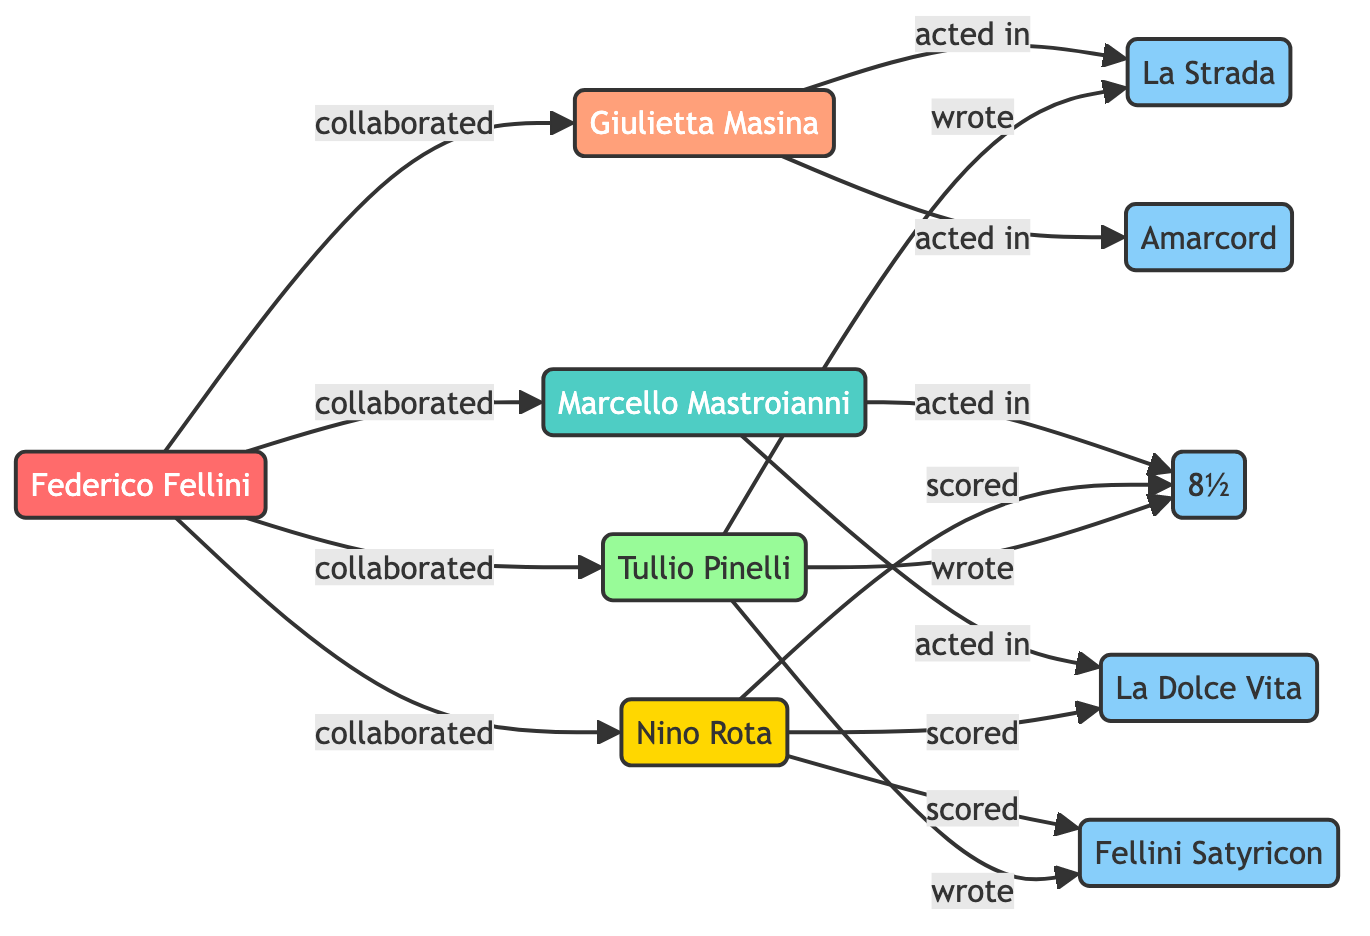What is Federico Fellini's role in the diagram? The diagram clearly shows that Federico Fellini is labeled as a director, which is indicated by the node containing his name and the class associated with directors.
Answer: director How many films are depicted in the diagram? By counting the film nodes in the diagram, there are five specific films listed: Amarcord, La Strada, 8½, La Dolce Vita, and Fellini Satyricon.
Answer: 5 Who acted in Amarcord? The diagram indicates that Giulietta Masina is connected to the Amarcord node, clearly showing she acted in this film.
Answer: Giulietta Masina Which composer worked with Fellini on 8½? The diagram connects Nino Rota as a composer that scored 8½, establishing the relationship through the lines connecting these nodes.
Answer: Nino Rota Which film did Tullio Pinelli write? The diagram illustrates that Tullio Pinelli is linked to La Strada, 8½, and Fellini Satyricon through writing relationships, so he wrote La Strada among others.
Answer: La Strada How many actors are mentioned in the diagram? By counting the actor nodes in the diagram, we see two actors mentioned: Marcello Mastroianni and Giulietta Masina.
Answer: 2 What two films did Marcello Mastroianni act in? The diagram shows that Marcello is connected to the nodes for 8½ and La Dolce Vita, indicating those are the films he acted in.
Answer: 8½ and La Dolce Vita What relationship connects Nino Rota and Fellini Satyricon? In the diagram, the line leading from Nino Rota to the Fellini Satyricon node indicates that he scored the film, thus establishing their connection.
Answer: scored How many collaborations does Fellini have with Marcello Mastroianni? The diagram depicts a single line connecting Fellini directly to Marcello Mastroianni labeled as a collaboration, indicating one collaboration.
Answer: 1 